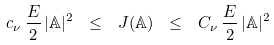Convert formula to latex. <formula><loc_0><loc_0><loc_500><loc_500>c _ { \nu } \, \frac { E } { 2 } \, | \mathbb { A } | ^ { 2 } \ \leq \ J ( { \mathbb { A } } ) \ \leq \ C _ { \nu } \, \frac { E } { 2 } \, | \mathbb { A } | ^ { 2 }</formula> 